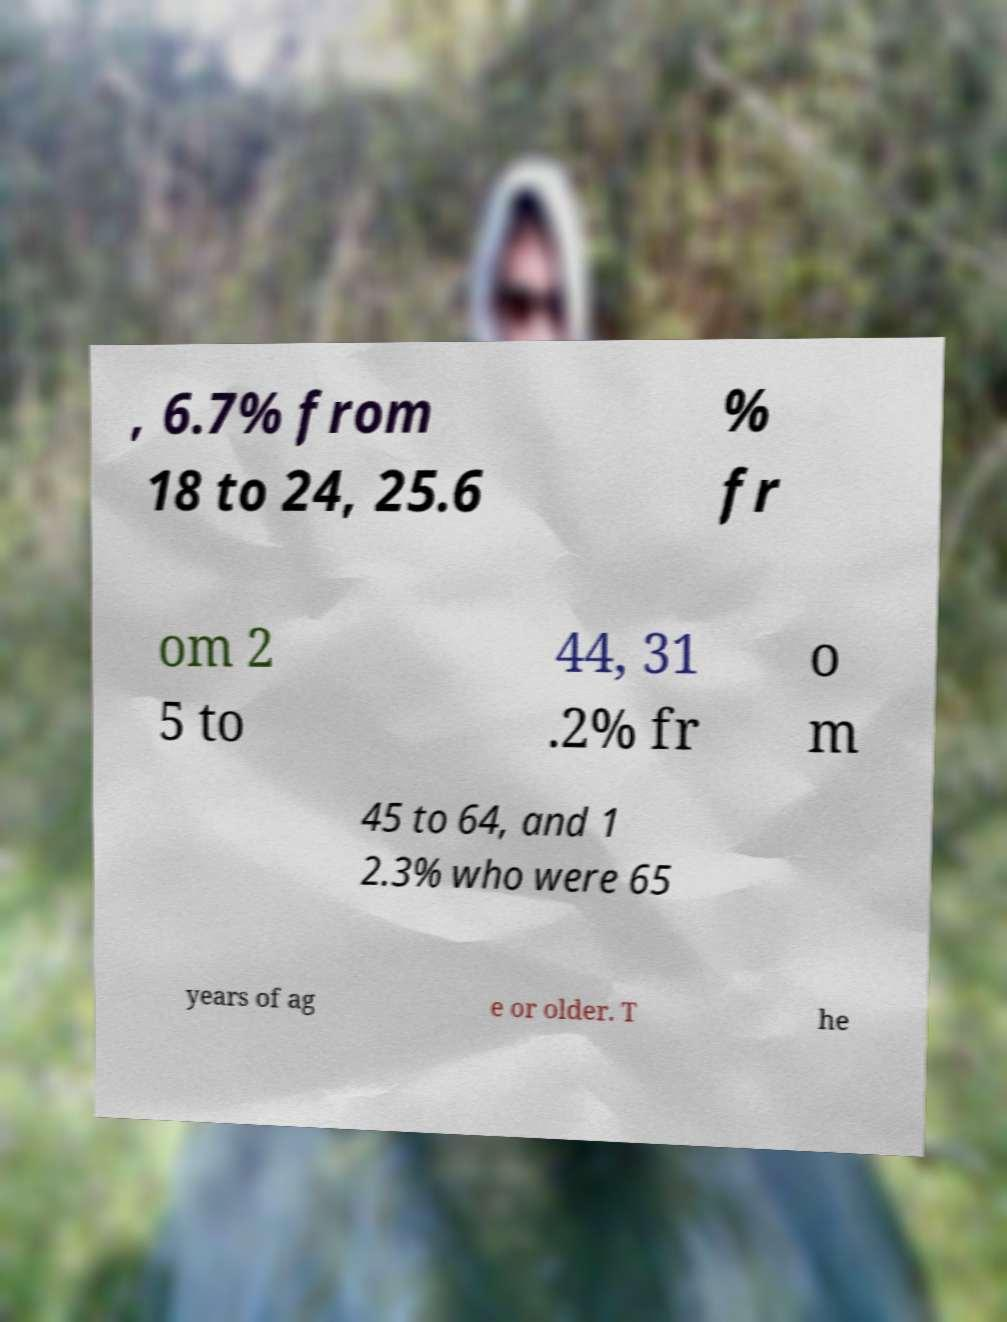Could you assist in decoding the text presented in this image and type it out clearly? , 6.7% from 18 to 24, 25.6 % fr om 2 5 to 44, 31 .2% fr o m 45 to 64, and 1 2.3% who were 65 years of ag e or older. T he 